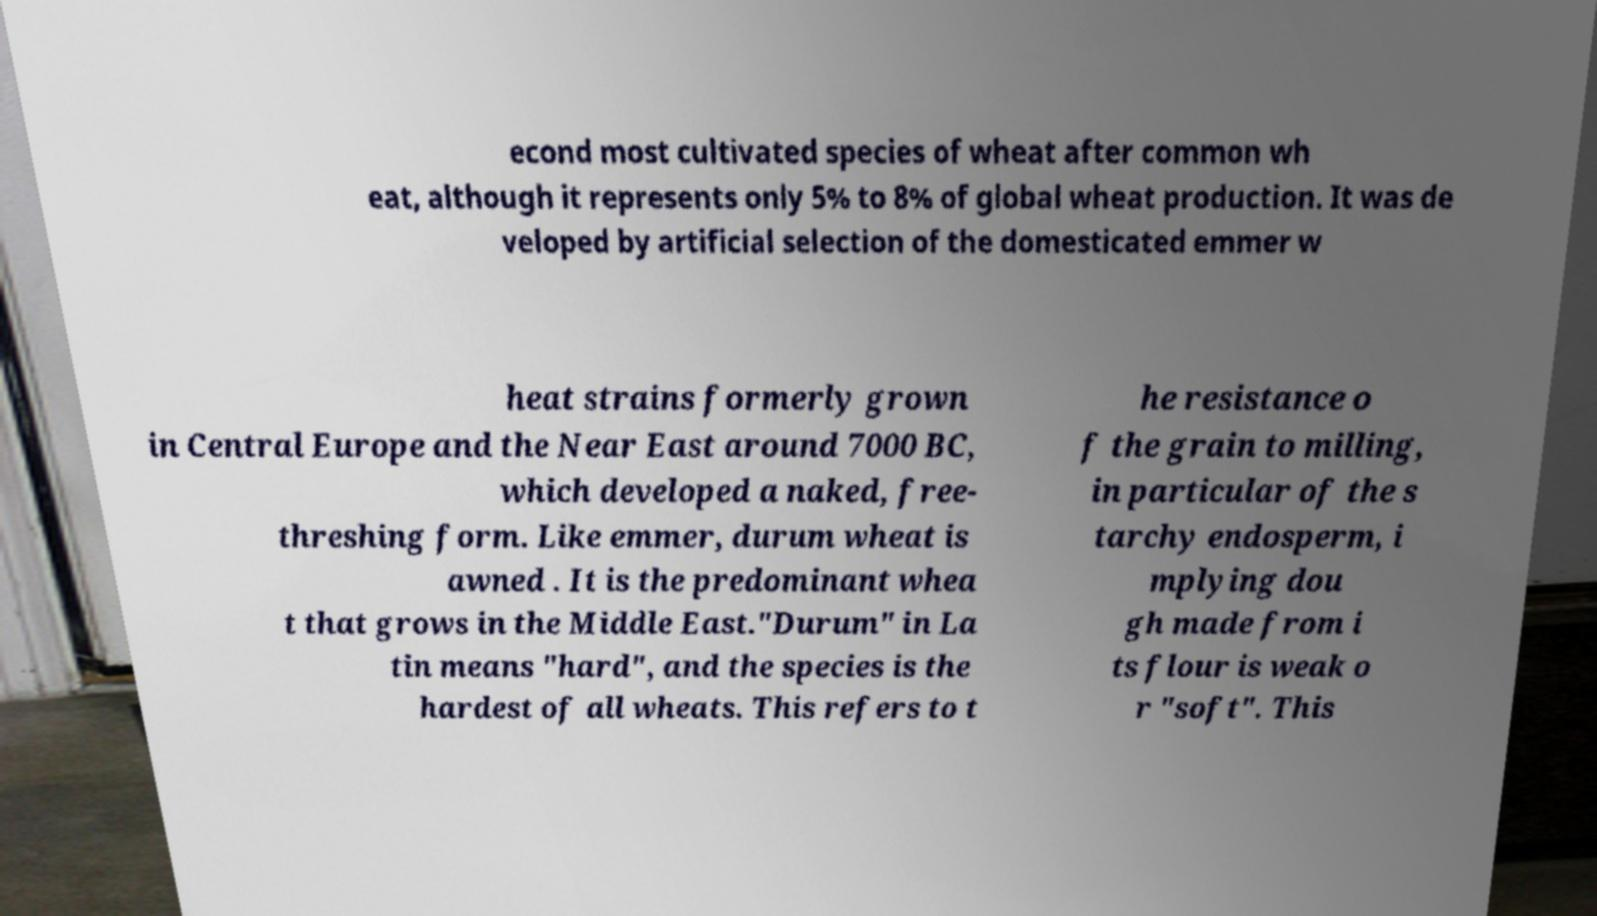Could you extract and type out the text from this image? econd most cultivated species of wheat after common wh eat, although it represents only 5% to 8% of global wheat production. It was de veloped by artificial selection of the domesticated emmer w heat strains formerly grown in Central Europe and the Near East around 7000 BC, which developed a naked, free- threshing form. Like emmer, durum wheat is awned . It is the predominant whea t that grows in the Middle East."Durum" in La tin means "hard", and the species is the hardest of all wheats. This refers to t he resistance o f the grain to milling, in particular of the s tarchy endosperm, i mplying dou gh made from i ts flour is weak o r "soft". This 